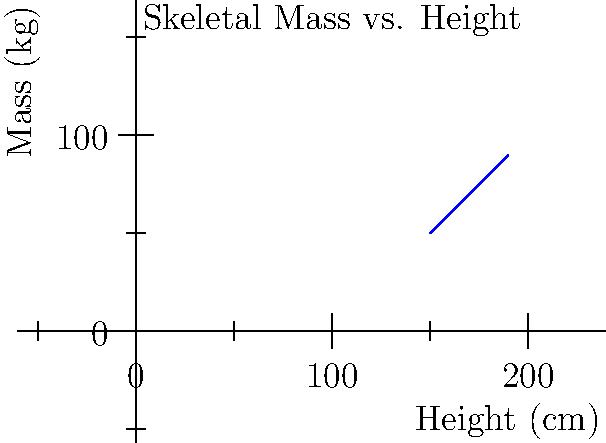As an intelligence agent, you've discovered skeletal remains at a suspected artifact smuggling site. Using the graph provided, which shows the relationship between skeletal height and estimated body mass, what would be the approximate body mass of an individual with a skeletal height of 175 cm? To estimate the body mass from the skeletal height, we need to follow these steps:

1. Locate the skeletal height of 175 cm on the x-axis of the graph.
2. Draw an imaginary vertical line from this point until it intersects with the blue line representing the relationship between height and mass.
3. From the intersection point, draw an imaginary horizontal line to the y-axis.
4. Read the corresponding value on the y-axis to determine the estimated body mass.

In this case:
1. 175 cm is between 170 cm and 180 cm on the x-axis.
2. The imaginary vertical line would intersect the blue line approximately halfway between the points for 170 cm and 180 cm.
3. The horizontal line from this intersection point would lead to a y-axis value between 70 kg and 80 kg.
4. By visual interpolation, we can estimate that the body mass for a 175 cm skeleton would be approximately 75 kg.

This method of estimation is crucial for intelligence agents to quickly assess potential suspects or victims in the field without advanced equipment.
Answer: 75 kg 